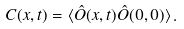<formula> <loc_0><loc_0><loc_500><loc_500>C ( x , t ) = \langle \hat { O } ( x , t ) \hat { O } ( 0 , 0 ) \rangle \, .</formula> 